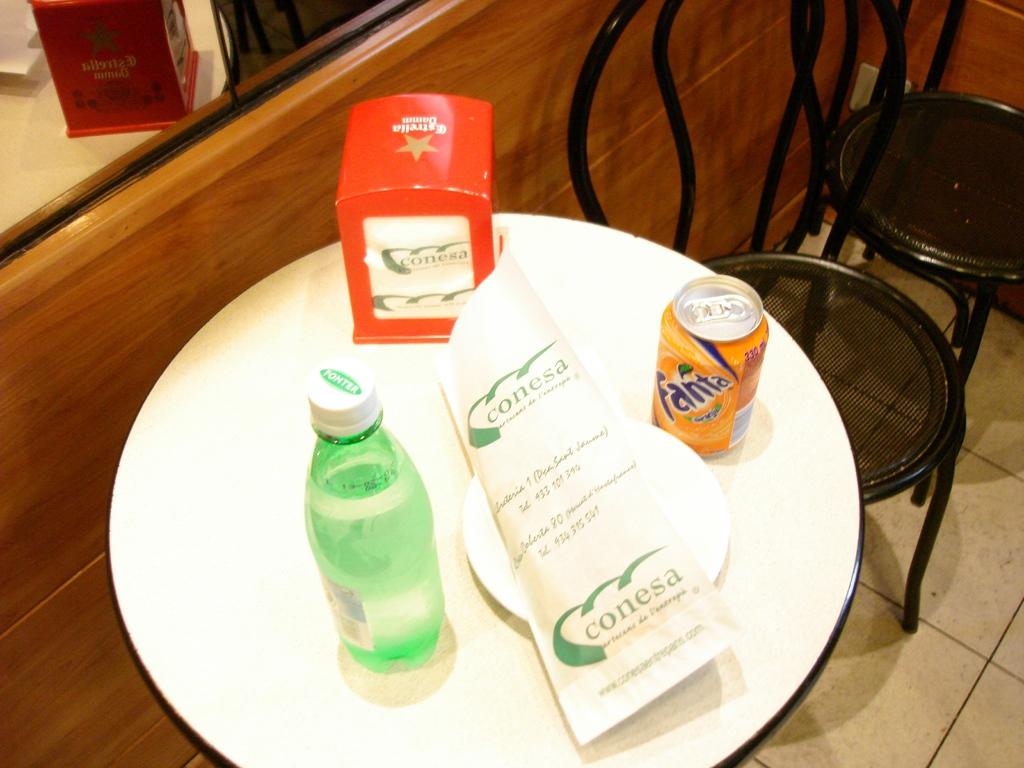What brand of beverage is in the green bottle?
Offer a terse response. Ponter. 